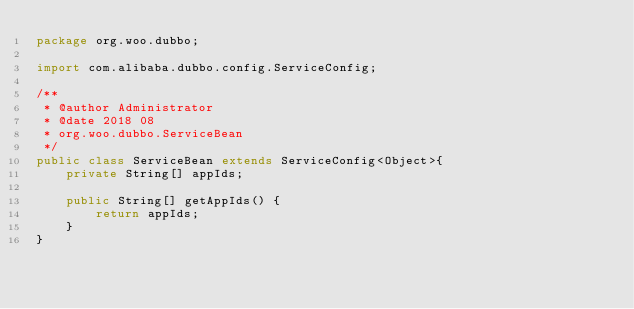Convert code to text. <code><loc_0><loc_0><loc_500><loc_500><_Java_>package org.woo.dubbo;

import com.alibaba.dubbo.config.ServiceConfig;

/**
 * @author Administrator
 * @date 2018 08
 * org.woo.dubbo.ServiceBean
 */
public class ServiceBean extends ServiceConfig<Object>{
    private String[] appIds;

    public String[] getAppIds() {
        return appIds;
    }
}
</code> 